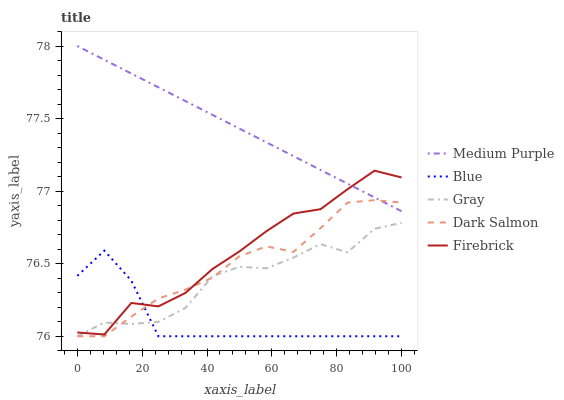Does Blue have the minimum area under the curve?
Answer yes or no. Yes. Does Medium Purple have the maximum area under the curve?
Answer yes or no. Yes. Does Firebrick have the minimum area under the curve?
Answer yes or no. No. Does Firebrick have the maximum area under the curve?
Answer yes or no. No. Is Medium Purple the smoothest?
Answer yes or no. Yes. Is Gray the roughest?
Answer yes or no. Yes. Is Blue the smoothest?
Answer yes or no. No. Is Blue the roughest?
Answer yes or no. No. Does Firebrick have the lowest value?
Answer yes or no. No. Does Firebrick have the highest value?
Answer yes or no. No. Is Blue less than Medium Purple?
Answer yes or no. Yes. Is Medium Purple greater than Blue?
Answer yes or no. Yes. Does Blue intersect Medium Purple?
Answer yes or no. No. 